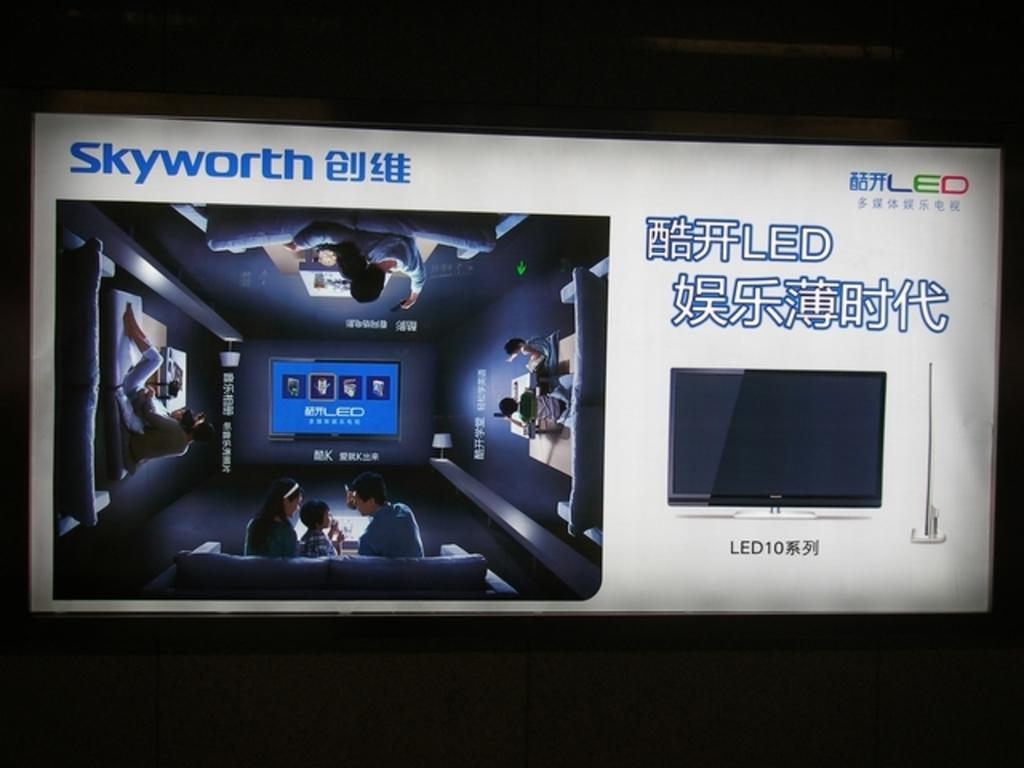<image>
Present a compact description of the photo's key features. Asian characters describe a Skyworth LED television on a screen. 